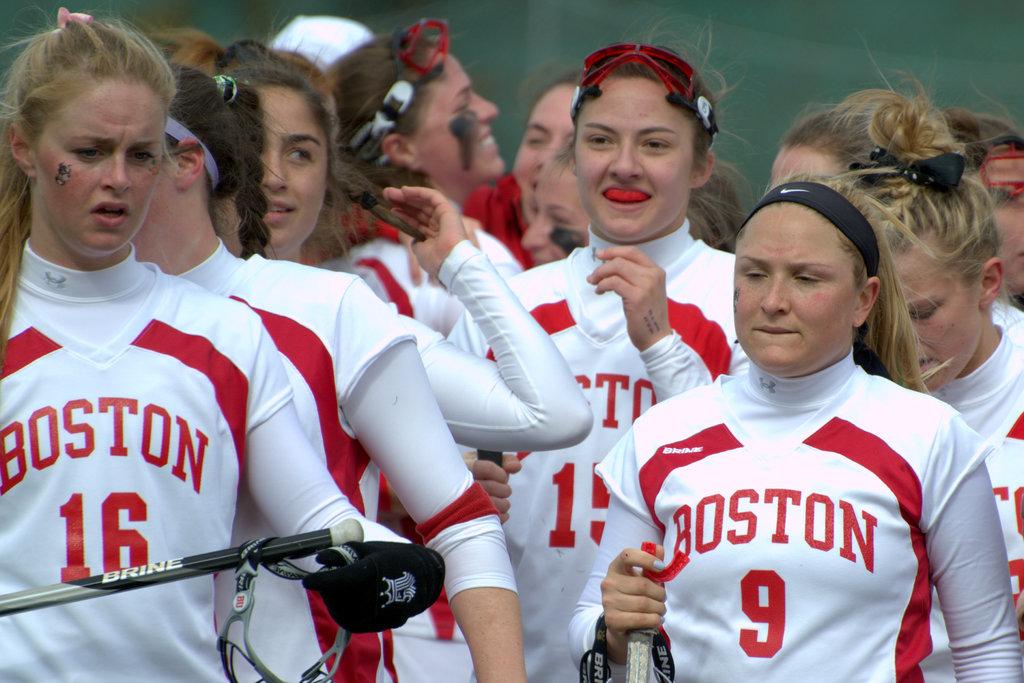What is the name of school on the shirt?
Give a very brief answer. Boston. What number is on the player with the black headband?
Provide a succinct answer. 9. 